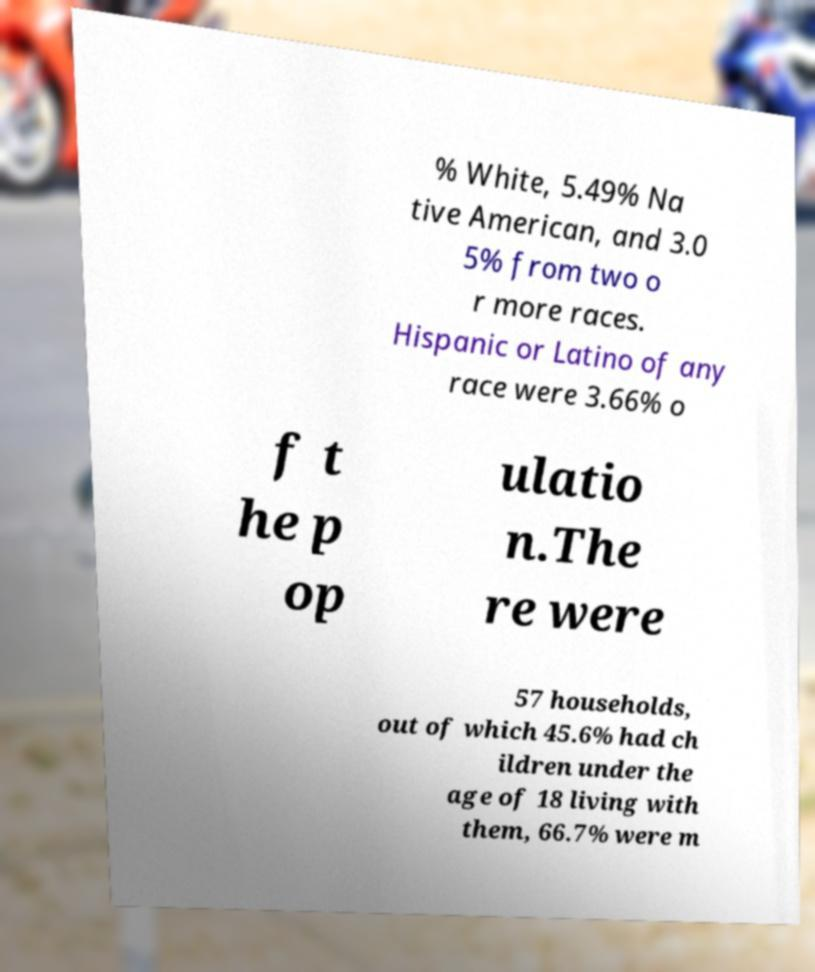For documentation purposes, I need the text within this image transcribed. Could you provide that? % White, 5.49% Na tive American, and 3.0 5% from two o r more races. Hispanic or Latino of any race were 3.66% o f t he p op ulatio n.The re were 57 households, out of which 45.6% had ch ildren under the age of 18 living with them, 66.7% were m 